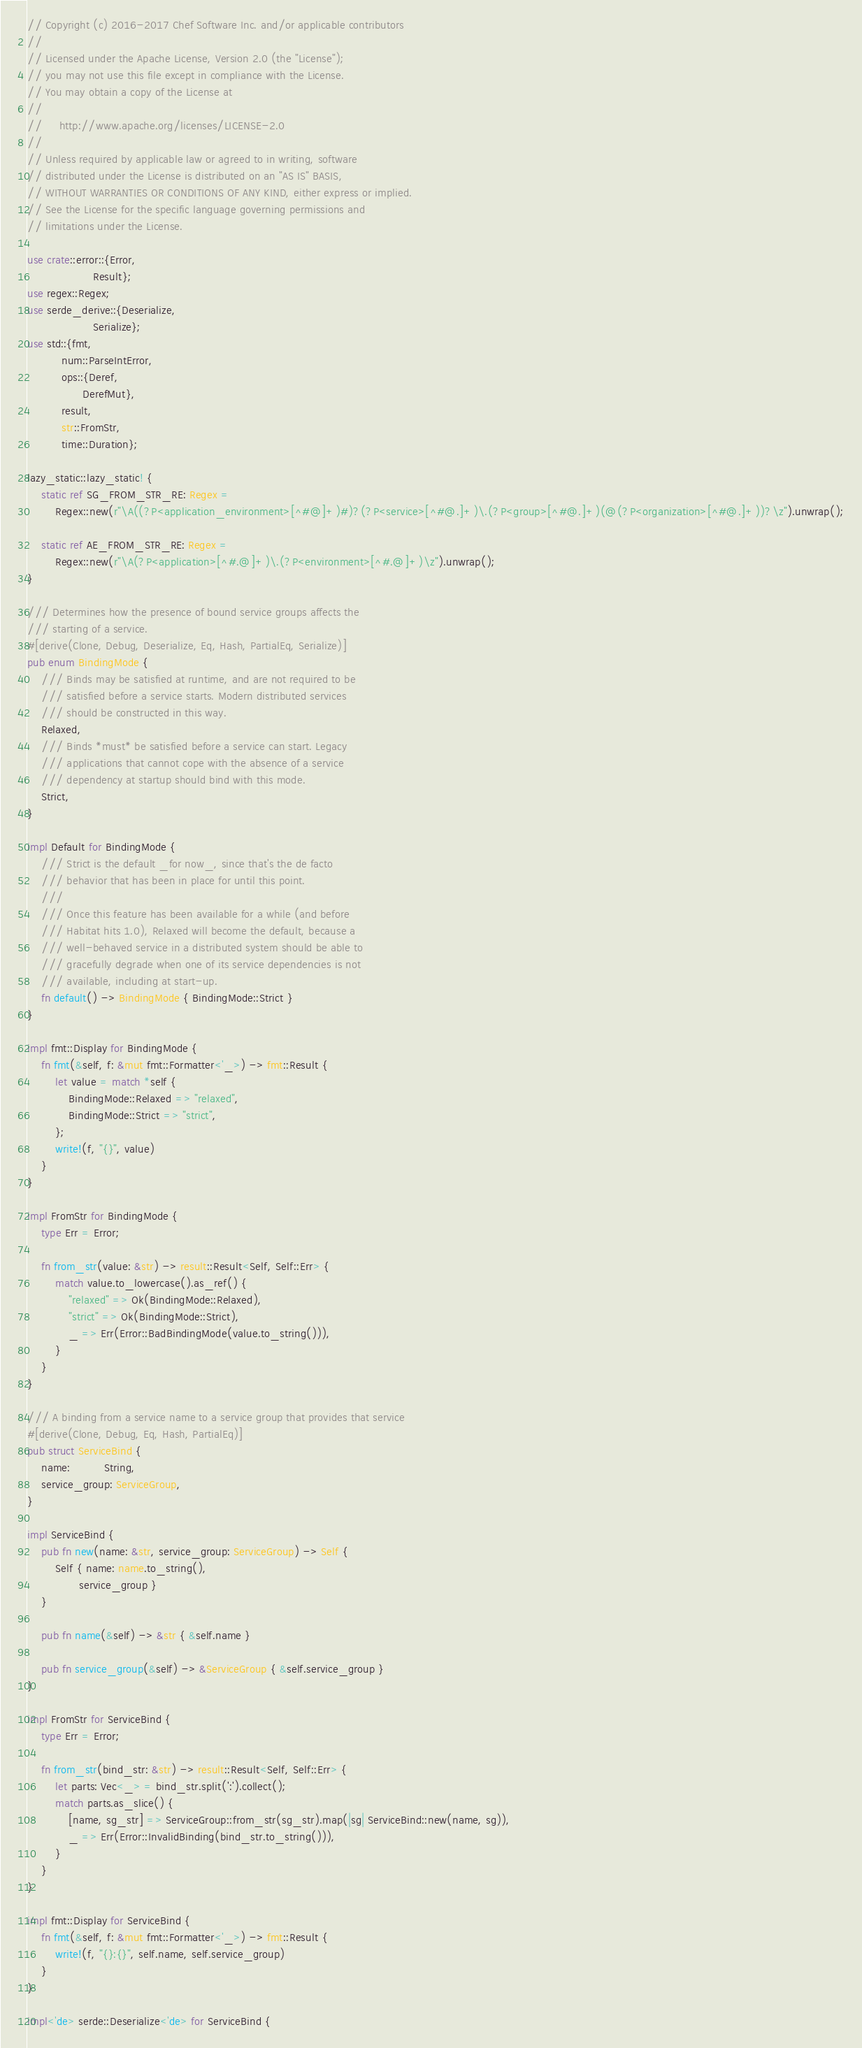<code> <loc_0><loc_0><loc_500><loc_500><_Rust_>// Copyright (c) 2016-2017 Chef Software Inc. and/or applicable contributors
//
// Licensed under the Apache License, Version 2.0 (the "License");
// you may not use this file except in compliance with the License.
// You may obtain a copy of the License at
//
//     http://www.apache.org/licenses/LICENSE-2.0
//
// Unless required by applicable law or agreed to in writing, software
// distributed under the License is distributed on an "AS IS" BASIS,
// WITHOUT WARRANTIES OR CONDITIONS OF ANY KIND, either express or implied.
// See the License for the specific language governing permissions and
// limitations under the License.

use crate::error::{Error,
                   Result};
use regex::Regex;
use serde_derive::{Deserialize,
                   Serialize};
use std::{fmt,
          num::ParseIntError,
          ops::{Deref,
                DerefMut},
          result,
          str::FromStr,
          time::Duration};

lazy_static::lazy_static! {
    static ref SG_FROM_STR_RE: Regex =
        Regex::new(r"\A((?P<application_environment>[^#@]+)#)?(?P<service>[^#@.]+)\.(?P<group>[^#@.]+)(@(?P<organization>[^#@.]+))?\z").unwrap();

    static ref AE_FROM_STR_RE: Regex =
        Regex::new(r"\A(?P<application>[^#.@]+)\.(?P<environment>[^#.@]+)\z").unwrap();
}

/// Determines how the presence of bound service groups affects the
/// starting of a service.
#[derive(Clone, Debug, Deserialize, Eq, Hash, PartialEq, Serialize)]
pub enum BindingMode {
    /// Binds may be satisfied at runtime, and are not required to be
    /// satisfied before a service starts. Modern distributed services
    /// should be constructed in this way.
    Relaxed,
    /// Binds *must* be satisfied before a service can start. Legacy
    /// applications that cannot cope with the absence of a service
    /// dependency at startup should bind with this mode.
    Strict,
}

impl Default for BindingMode {
    /// Strict is the default _for now_, since that's the de facto
    /// behavior that has been in place for until this point.
    ///
    /// Once this feature has been available for a while (and before
    /// Habitat hits 1.0), Relaxed will become the default, because a
    /// well-behaved service in a distributed system should be able to
    /// gracefully degrade when one of its service dependencies is not
    /// available, including at start-up.
    fn default() -> BindingMode { BindingMode::Strict }
}

impl fmt::Display for BindingMode {
    fn fmt(&self, f: &mut fmt::Formatter<'_>) -> fmt::Result {
        let value = match *self {
            BindingMode::Relaxed => "relaxed",
            BindingMode::Strict => "strict",
        };
        write!(f, "{}", value)
    }
}

impl FromStr for BindingMode {
    type Err = Error;

    fn from_str(value: &str) -> result::Result<Self, Self::Err> {
        match value.to_lowercase().as_ref() {
            "relaxed" => Ok(BindingMode::Relaxed),
            "strict" => Ok(BindingMode::Strict),
            _ => Err(Error::BadBindingMode(value.to_string())),
        }
    }
}

/// A binding from a service name to a service group that provides that service
#[derive(Clone, Debug, Eq, Hash, PartialEq)]
pub struct ServiceBind {
    name:          String,
    service_group: ServiceGroup,
}

impl ServiceBind {
    pub fn new(name: &str, service_group: ServiceGroup) -> Self {
        Self { name: name.to_string(),
               service_group }
    }

    pub fn name(&self) -> &str { &self.name }

    pub fn service_group(&self) -> &ServiceGroup { &self.service_group }
}

impl FromStr for ServiceBind {
    type Err = Error;

    fn from_str(bind_str: &str) -> result::Result<Self, Self::Err> {
        let parts: Vec<_> = bind_str.split(':').collect();
        match parts.as_slice() {
            [name, sg_str] => ServiceGroup::from_str(sg_str).map(|sg| ServiceBind::new(name, sg)),
            _ => Err(Error::InvalidBinding(bind_str.to_string())),
        }
    }
}

impl fmt::Display for ServiceBind {
    fn fmt(&self, f: &mut fmt::Formatter<'_>) -> fmt::Result {
        write!(f, "{}:{}", self.name, self.service_group)
    }
}

impl<'de> serde::Deserialize<'de> for ServiceBind {</code> 